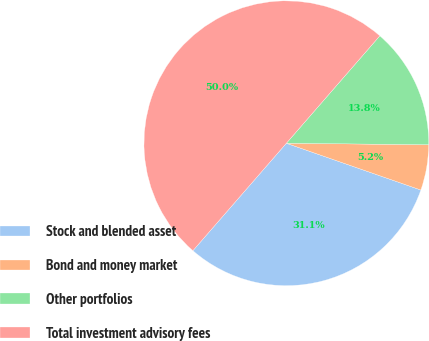Convert chart to OTSL. <chart><loc_0><loc_0><loc_500><loc_500><pie_chart><fcel>Stock and blended asset<fcel>Bond and money market<fcel>Other portfolios<fcel>Total investment advisory fees<nl><fcel>31.07%<fcel>5.16%<fcel>13.77%<fcel>50.0%<nl></chart> 